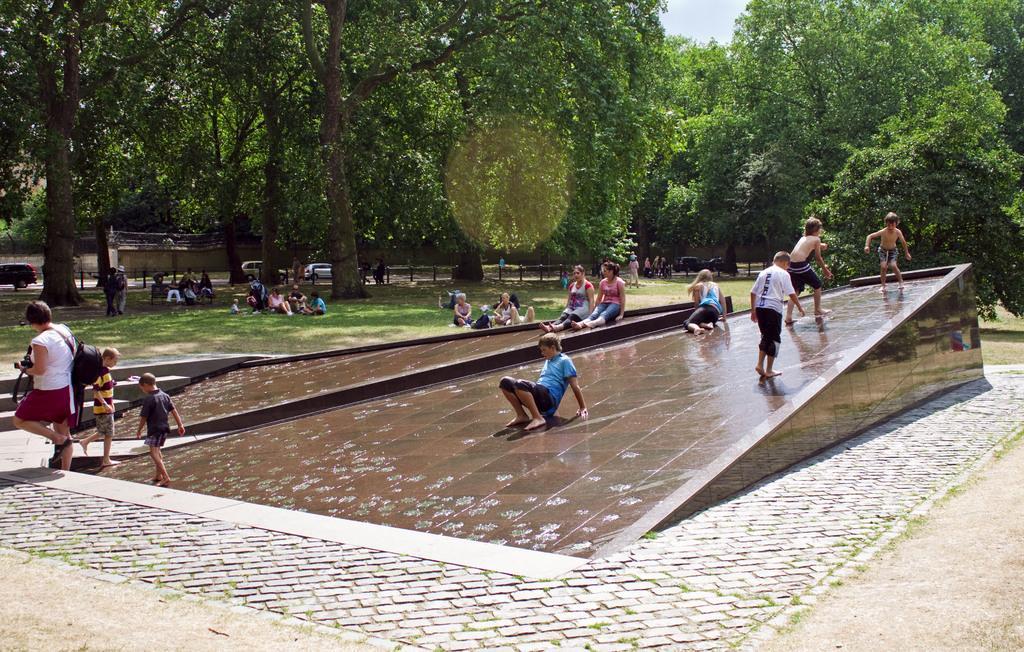Please provide a concise description of this image. In this picture I can see group of people, ramps. I can see vehicles on the road. There are trees, and in the background there is the sky. 